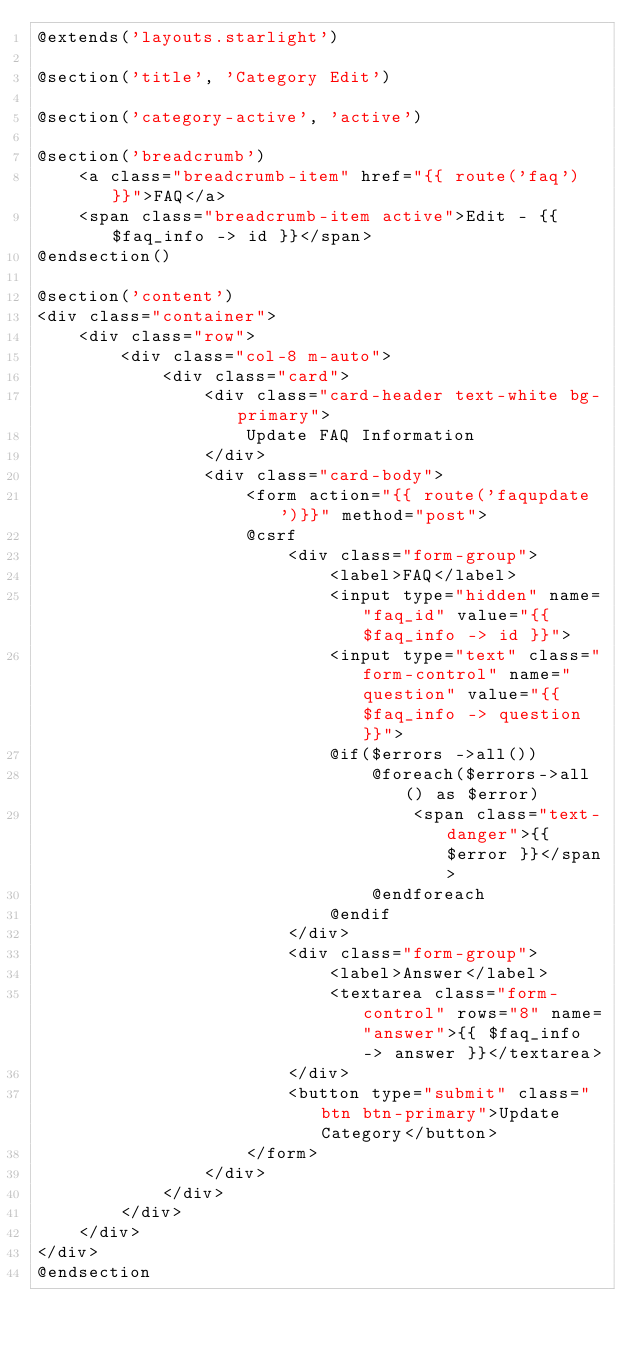Convert code to text. <code><loc_0><loc_0><loc_500><loc_500><_PHP_>@extends('layouts.starlight')

@section('title', 'Category Edit')

@section('category-active', 'active')

@section('breadcrumb')
    <a class="breadcrumb-item" href="{{ route('faq') }}">FAQ</a>
    <span class="breadcrumb-item active">Edit - {{ $faq_info -> id }}</span>
@endsection()

@section('content')
<div class="container">
    <div class="row">
        <div class="col-8 m-auto">
            <div class="card">
                <div class="card-header text-white bg-primary">
                    Update FAQ Information
                </div>
                <div class="card-body">
                    <form action="{{ route('faqupdate')}}" method="post">
                    @csrf
                        <div class="form-group">
                            <label>FAQ</label>
                            <input type="hidden" name="faq_id" value="{{ $faq_info -> id }}">
                            <input type="text" class="form-control" name="question" value="{{ $faq_info -> question }}">
                            @if($errors ->all())
                                @foreach($errors->all() as $error)
                                    <span class="text-danger">{{ $error }}</span>
                                @endforeach
                            @endif
                        </div>
                        <div class="form-group">
                            <label>Answer</label>
                            <textarea class="form-control" rows="8" name="answer">{{ $faq_info -> answer }}</textarea>
                        </div>
                        <button type="submit" class="btn btn-primary">Update Category</button>
                    </form>
                </div>
            </div>
        </div>
    </div>
</div>
@endsection</code> 